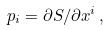<formula> <loc_0><loc_0><loc_500><loc_500>p _ { i } = \partial S / \partial x ^ { i } \, ,</formula> 